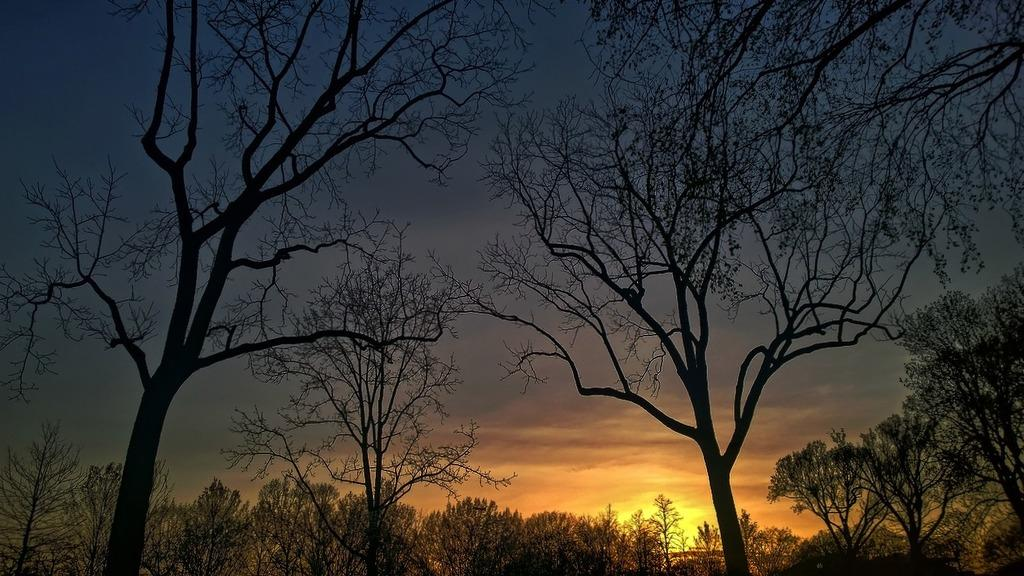What type of natural vegetation can be seen in the image? There are trees in the image. What part of the natural environment is visible in the image? The sky is visible in the image. Can you describe the colors of the sky in the image? The colors of the sky include yellow, orange, grey, and blue. Are there any pigs swimming in the sky in the image? No, there are no pigs or swimming activity present in the image. 